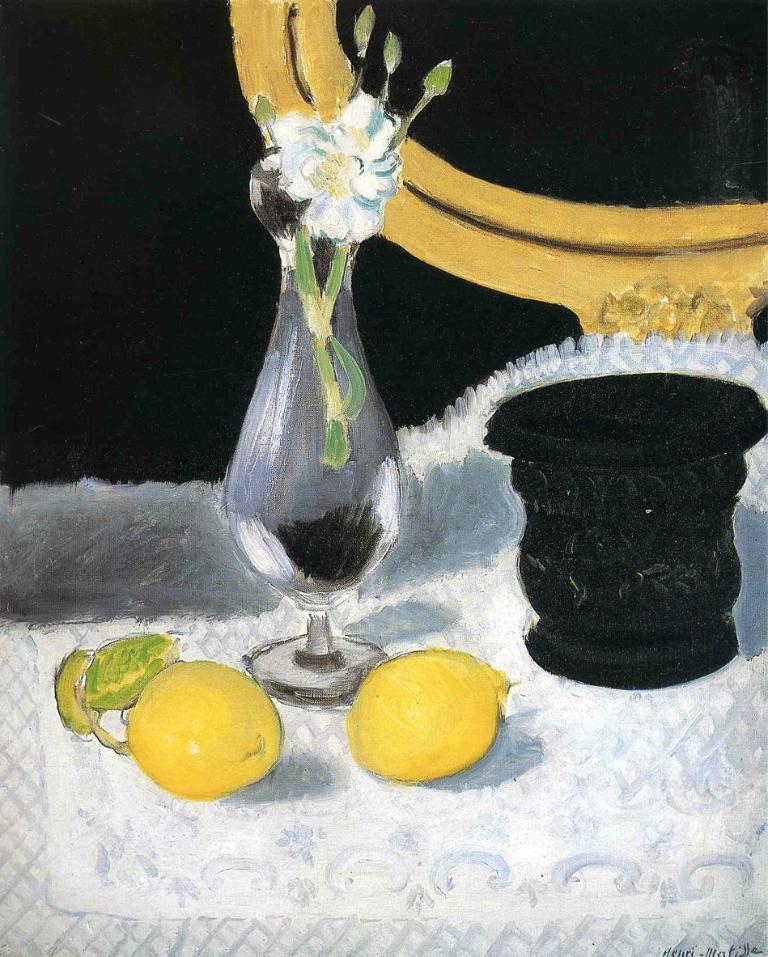Could you give a brief overview of what you see in this image? In this image, we can see the painting. We can see a white colored object with a few fruits, a flower pot and an object. We can also see the background and an object on the top and on the right. 